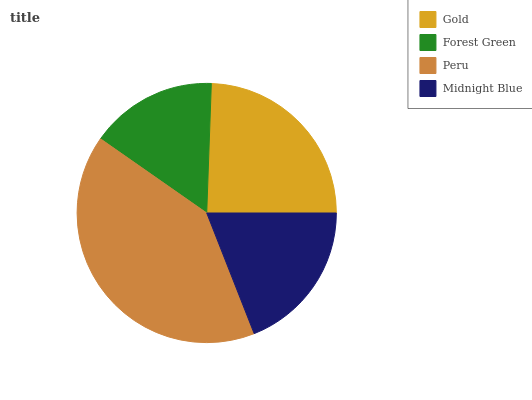Is Forest Green the minimum?
Answer yes or no. Yes. Is Peru the maximum?
Answer yes or no. Yes. Is Peru the minimum?
Answer yes or no. No. Is Forest Green the maximum?
Answer yes or no. No. Is Peru greater than Forest Green?
Answer yes or no. Yes. Is Forest Green less than Peru?
Answer yes or no. Yes. Is Forest Green greater than Peru?
Answer yes or no. No. Is Peru less than Forest Green?
Answer yes or no. No. Is Gold the high median?
Answer yes or no. Yes. Is Midnight Blue the low median?
Answer yes or no. Yes. Is Midnight Blue the high median?
Answer yes or no. No. Is Gold the low median?
Answer yes or no. No. 